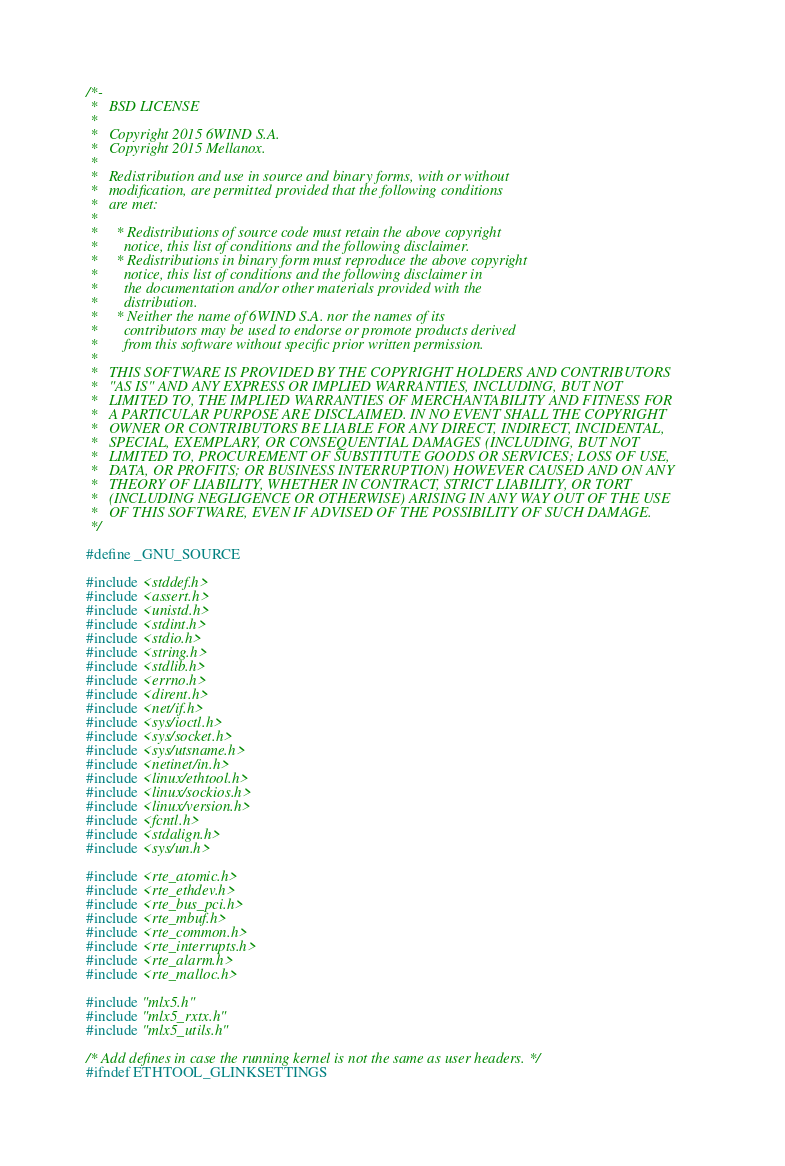Convert code to text. <code><loc_0><loc_0><loc_500><loc_500><_C_>/*-
 *   BSD LICENSE
 *
 *   Copyright 2015 6WIND S.A.
 *   Copyright 2015 Mellanox.
 *
 *   Redistribution and use in source and binary forms, with or without
 *   modification, are permitted provided that the following conditions
 *   are met:
 *
 *     * Redistributions of source code must retain the above copyright
 *       notice, this list of conditions and the following disclaimer.
 *     * Redistributions in binary form must reproduce the above copyright
 *       notice, this list of conditions and the following disclaimer in
 *       the documentation and/or other materials provided with the
 *       distribution.
 *     * Neither the name of 6WIND S.A. nor the names of its
 *       contributors may be used to endorse or promote products derived
 *       from this software without specific prior written permission.
 *
 *   THIS SOFTWARE IS PROVIDED BY THE COPYRIGHT HOLDERS AND CONTRIBUTORS
 *   "AS IS" AND ANY EXPRESS OR IMPLIED WARRANTIES, INCLUDING, BUT NOT
 *   LIMITED TO, THE IMPLIED WARRANTIES OF MERCHANTABILITY AND FITNESS FOR
 *   A PARTICULAR PURPOSE ARE DISCLAIMED. IN NO EVENT SHALL THE COPYRIGHT
 *   OWNER OR CONTRIBUTORS BE LIABLE FOR ANY DIRECT, INDIRECT, INCIDENTAL,
 *   SPECIAL, EXEMPLARY, OR CONSEQUENTIAL DAMAGES (INCLUDING, BUT NOT
 *   LIMITED TO, PROCUREMENT OF SUBSTITUTE GOODS OR SERVICES; LOSS OF USE,
 *   DATA, OR PROFITS; OR BUSINESS INTERRUPTION) HOWEVER CAUSED AND ON ANY
 *   THEORY OF LIABILITY, WHETHER IN CONTRACT, STRICT LIABILITY, OR TORT
 *   (INCLUDING NEGLIGENCE OR OTHERWISE) ARISING IN ANY WAY OUT OF THE USE
 *   OF THIS SOFTWARE, EVEN IF ADVISED OF THE POSSIBILITY OF SUCH DAMAGE.
 */

#define _GNU_SOURCE

#include <stddef.h>
#include <assert.h>
#include <unistd.h>
#include <stdint.h>
#include <stdio.h>
#include <string.h>
#include <stdlib.h>
#include <errno.h>
#include <dirent.h>
#include <net/if.h>
#include <sys/ioctl.h>
#include <sys/socket.h>
#include <sys/utsname.h>
#include <netinet/in.h>
#include <linux/ethtool.h>
#include <linux/sockios.h>
#include <linux/version.h>
#include <fcntl.h>
#include <stdalign.h>
#include <sys/un.h>

#include <rte_atomic.h>
#include <rte_ethdev.h>
#include <rte_bus_pci.h>
#include <rte_mbuf.h>
#include <rte_common.h>
#include <rte_interrupts.h>
#include <rte_alarm.h>
#include <rte_malloc.h>

#include "mlx5.h"
#include "mlx5_rxtx.h"
#include "mlx5_utils.h"

/* Add defines in case the running kernel is not the same as user headers. */
#ifndef ETHTOOL_GLINKSETTINGS</code> 